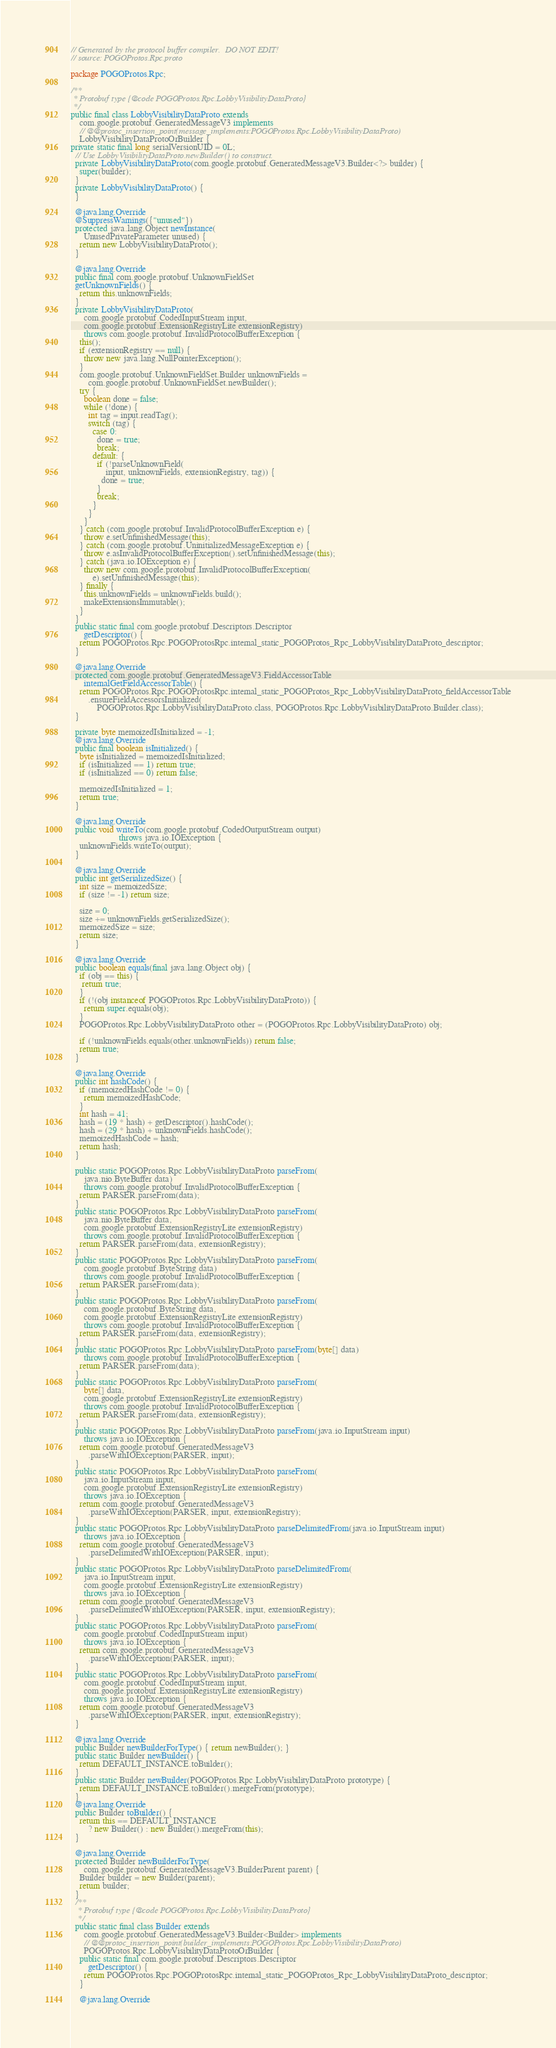<code> <loc_0><loc_0><loc_500><loc_500><_Java_>// Generated by the protocol buffer compiler.  DO NOT EDIT!
// source: POGOProtos.Rpc.proto

package POGOProtos.Rpc;

/**
 * Protobuf type {@code POGOProtos.Rpc.LobbyVisibilityDataProto}
 */
public final class LobbyVisibilityDataProto extends
    com.google.protobuf.GeneratedMessageV3 implements
    // @@protoc_insertion_point(message_implements:POGOProtos.Rpc.LobbyVisibilityDataProto)
    LobbyVisibilityDataProtoOrBuilder {
private static final long serialVersionUID = 0L;
  // Use LobbyVisibilityDataProto.newBuilder() to construct.
  private LobbyVisibilityDataProto(com.google.protobuf.GeneratedMessageV3.Builder<?> builder) {
    super(builder);
  }
  private LobbyVisibilityDataProto() {
  }

  @java.lang.Override
  @SuppressWarnings({"unused"})
  protected java.lang.Object newInstance(
      UnusedPrivateParameter unused) {
    return new LobbyVisibilityDataProto();
  }

  @java.lang.Override
  public final com.google.protobuf.UnknownFieldSet
  getUnknownFields() {
    return this.unknownFields;
  }
  private LobbyVisibilityDataProto(
      com.google.protobuf.CodedInputStream input,
      com.google.protobuf.ExtensionRegistryLite extensionRegistry)
      throws com.google.protobuf.InvalidProtocolBufferException {
    this();
    if (extensionRegistry == null) {
      throw new java.lang.NullPointerException();
    }
    com.google.protobuf.UnknownFieldSet.Builder unknownFields =
        com.google.protobuf.UnknownFieldSet.newBuilder();
    try {
      boolean done = false;
      while (!done) {
        int tag = input.readTag();
        switch (tag) {
          case 0:
            done = true;
            break;
          default: {
            if (!parseUnknownField(
                input, unknownFields, extensionRegistry, tag)) {
              done = true;
            }
            break;
          }
        }
      }
    } catch (com.google.protobuf.InvalidProtocolBufferException e) {
      throw e.setUnfinishedMessage(this);
    } catch (com.google.protobuf.UninitializedMessageException e) {
      throw e.asInvalidProtocolBufferException().setUnfinishedMessage(this);
    } catch (java.io.IOException e) {
      throw new com.google.protobuf.InvalidProtocolBufferException(
          e).setUnfinishedMessage(this);
    } finally {
      this.unknownFields = unknownFields.build();
      makeExtensionsImmutable();
    }
  }
  public static final com.google.protobuf.Descriptors.Descriptor
      getDescriptor() {
    return POGOProtos.Rpc.POGOProtosRpc.internal_static_POGOProtos_Rpc_LobbyVisibilityDataProto_descriptor;
  }

  @java.lang.Override
  protected com.google.protobuf.GeneratedMessageV3.FieldAccessorTable
      internalGetFieldAccessorTable() {
    return POGOProtos.Rpc.POGOProtosRpc.internal_static_POGOProtos_Rpc_LobbyVisibilityDataProto_fieldAccessorTable
        .ensureFieldAccessorsInitialized(
            POGOProtos.Rpc.LobbyVisibilityDataProto.class, POGOProtos.Rpc.LobbyVisibilityDataProto.Builder.class);
  }

  private byte memoizedIsInitialized = -1;
  @java.lang.Override
  public final boolean isInitialized() {
    byte isInitialized = memoizedIsInitialized;
    if (isInitialized == 1) return true;
    if (isInitialized == 0) return false;

    memoizedIsInitialized = 1;
    return true;
  }

  @java.lang.Override
  public void writeTo(com.google.protobuf.CodedOutputStream output)
                      throws java.io.IOException {
    unknownFields.writeTo(output);
  }

  @java.lang.Override
  public int getSerializedSize() {
    int size = memoizedSize;
    if (size != -1) return size;

    size = 0;
    size += unknownFields.getSerializedSize();
    memoizedSize = size;
    return size;
  }

  @java.lang.Override
  public boolean equals(final java.lang.Object obj) {
    if (obj == this) {
     return true;
    }
    if (!(obj instanceof POGOProtos.Rpc.LobbyVisibilityDataProto)) {
      return super.equals(obj);
    }
    POGOProtos.Rpc.LobbyVisibilityDataProto other = (POGOProtos.Rpc.LobbyVisibilityDataProto) obj;

    if (!unknownFields.equals(other.unknownFields)) return false;
    return true;
  }

  @java.lang.Override
  public int hashCode() {
    if (memoizedHashCode != 0) {
      return memoizedHashCode;
    }
    int hash = 41;
    hash = (19 * hash) + getDescriptor().hashCode();
    hash = (29 * hash) + unknownFields.hashCode();
    memoizedHashCode = hash;
    return hash;
  }

  public static POGOProtos.Rpc.LobbyVisibilityDataProto parseFrom(
      java.nio.ByteBuffer data)
      throws com.google.protobuf.InvalidProtocolBufferException {
    return PARSER.parseFrom(data);
  }
  public static POGOProtos.Rpc.LobbyVisibilityDataProto parseFrom(
      java.nio.ByteBuffer data,
      com.google.protobuf.ExtensionRegistryLite extensionRegistry)
      throws com.google.protobuf.InvalidProtocolBufferException {
    return PARSER.parseFrom(data, extensionRegistry);
  }
  public static POGOProtos.Rpc.LobbyVisibilityDataProto parseFrom(
      com.google.protobuf.ByteString data)
      throws com.google.protobuf.InvalidProtocolBufferException {
    return PARSER.parseFrom(data);
  }
  public static POGOProtos.Rpc.LobbyVisibilityDataProto parseFrom(
      com.google.protobuf.ByteString data,
      com.google.protobuf.ExtensionRegistryLite extensionRegistry)
      throws com.google.protobuf.InvalidProtocolBufferException {
    return PARSER.parseFrom(data, extensionRegistry);
  }
  public static POGOProtos.Rpc.LobbyVisibilityDataProto parseFrom(byte[] data)
      throws com.google.protobuf.InvalidProtocolBufferException {
    return PARSER.parseFrom(data);
  }
  public static POGOProtos.Rpc.LobbyVisibilityDataProto parseFrom(
      byte[] data,
      com.google.protobuf.ExtensionRegistryLite extensionRegistry)
      throws com.google.protobuf.InvalidProtocolBufferException {
    return PARSER.parseFrom(data, extensionRegistry);
  }
  public static POGOProtos.Rpc.LobbyVisibilityDataProto parseFrom(java.io.InputStream input)
      throws java.io.IOException {
    return com.google.protobuf.GeneratedMessageV3
        .parseWithIOException(PARSER, input);
  }
  public static POGOProtos.Rpc.LobbyVisibilityDataProto parseFrom(
      java.io.InputStream input,
      com.google.protobuf.ExtensionRegistryLite extensionRegistry)
      throws java.io.IOException {
    return com.google.protobuf.GeneratedMessageV3
        .parseWithIOException(PARSER, input, extensionRegistry);
  }
  public static POGOProtos.Rpc.LobbyVisibilityDataProto parseDelimitedFrom(java.io.InputStream input)
      throws java.io.IOException {
    return com.google.protobuf.GeneratedMessageV3
        .parseDelimitedWithIOException(PARSER, input);
  }
  public static POGOProtos.Rpc.LobbyVisibilityDataProto parseDelimitedFrom(
      java.io.InputStream input,
      com.google.protobuf.ExtensionRegistryLite extensionRegistry)
      throws java.io.IOException {
    return com.google.protobuf.GeneratedMessageV3
        .parseDelimitedWithIOException(PARSER, input, extensionRegistry);
  }
  public static POGOProtos.Rpc.LobbyVisibilityDataProto parseFrom(
      com.google.protobuf.CodedInputStream input)
      throws java.io.IOException {
    return com.google.protobuf.GeneratedMessageV3
        .parseWithIOException(PARSER, input);
  }
  public static POGOProtos.Rpc.LobbyVisibilityDataProto parseFrom(
      com.google.protobuf.CodedInputStream input,
      com.google.protobuf.ExtensionRegistryLite extensionRegistry)
      throws java.io.IOException {
    return com.google.protobuf.GeneratedMessageV3
        .parseWithIOException(PARSER, input, extensionRegistry);
  }

  @java.lang.Override
  public Builder newBuilderForType() { return newBuilder(); }
  public static Builder newBuilder() {
    return DEFAULT_INSTANCE.toBuilder();
  }
  public static Builder newBuilder(POGOProtos.Rpc.LobbyVisibilityDataProto prototype) {
    return DEFAULT_INSTANCE.toBuilder().mergeFrom(prototype);
  }
  @java.lang.Override
  public Builder toBuilder() {
    return this == DEFAULT_INSTANCE
        ? new Builder() : new Builder().mergeFrom(this);
  }

  @java.lang.Override
  protected Builder newBuilderForType(
      com.google.protobuf.GeneratedMessageV3.BuilderParent parent) {
    Builder builder = new Builder(parent);
    return builder;
  }
  /**
   * Protobuf type {@code POGOProtos.Rpc.LobbyVisibilityDataProto}
   */
  public static final class Builder extends
      com.google.protobuf.GeneratedMessageV3.Builder<Builder> implements
      // @@protoc_insertion_point(builder_implements:POGOProtos.Rpc.LobbyVisibilityDataProto)
      POGOProtos.Rpc.LobbyVisibilityDataProtoOrBuilder {
    public static final com.google.protobuf.Descriptors.Descriptor
        getDescriptor() {
      return POGOProtos.Rpc.POGOProtosRpc.internal_static_POGOProtos_Rpc_LobbyVisibilityDataProto_descriptor;
    }

    @java.lang.Override</code> 